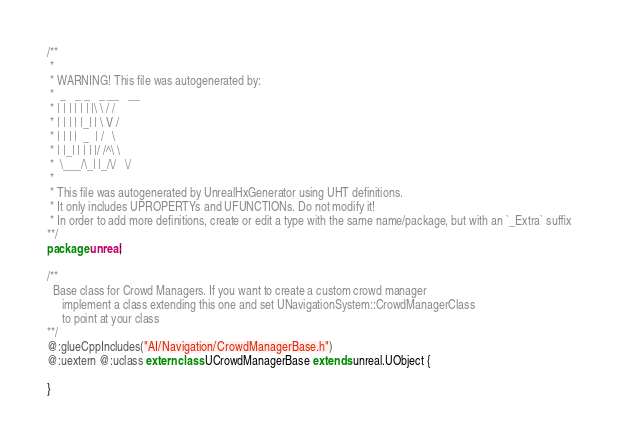Convert code to text. <code><loc_0><loc_0><loc_500><loc_500><_Haxe_>/**
 * 
 * WARNING! This file was autogenerated by: 
 *  _   _ _   _ __   __ 
 * | | | | | | |\ \ / / 
 * | | | | |_| | \ V /  
 * | | | |  _  | /   \  
 * | |_| | | | |/ /^\ \ 
 *  \___/\_| |_/\/   \/ 
 * 
 * This file was autogenerated by UnrealHxGenerator using UHT definitions.
 * It only includes UPROPERTYs and UFUNCTIONs. Do not modify it!
 * In order to add more definitions, create or edit a type with the same name/package, but with an `_Extra` suffix
**/
package unreal;

/**
  Base class for Crowd Managers. If you want to create a custom crowd manager
     implement a class extending this one and set UNavigationSystem::CrowdManagerClass
     to point at your class
**/
@:glueCppIncludes("AI/Navigation/CrowdManagerBase.h")
@:uextern @:uclass extern class UCrowdManagerBase extends unreal.UObject {
  
}
</code> 